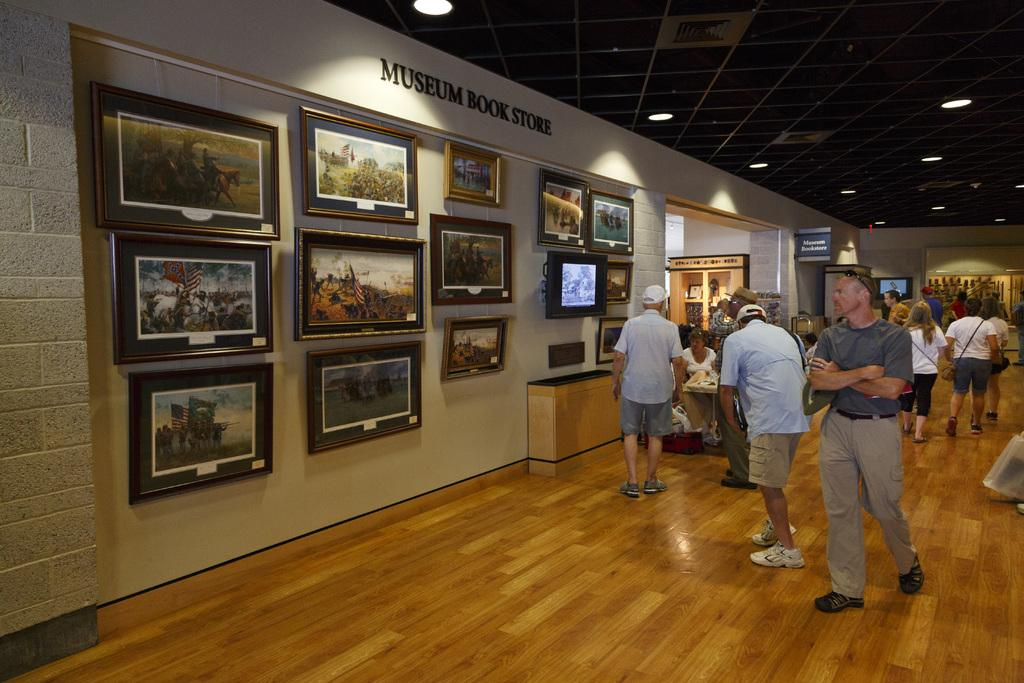What type of establishment is depicted in the image? There is a museum book store in the image. What can be seen on the left side of the image? There are paintings on the wall on the left side of the image. What is happening on the right side of the image? There are many people on the right side of the image. Can you tell me what the goldfish are discussing in the image? There are no goldfish present in the image, and therefore no discussion involving them can be observed. 